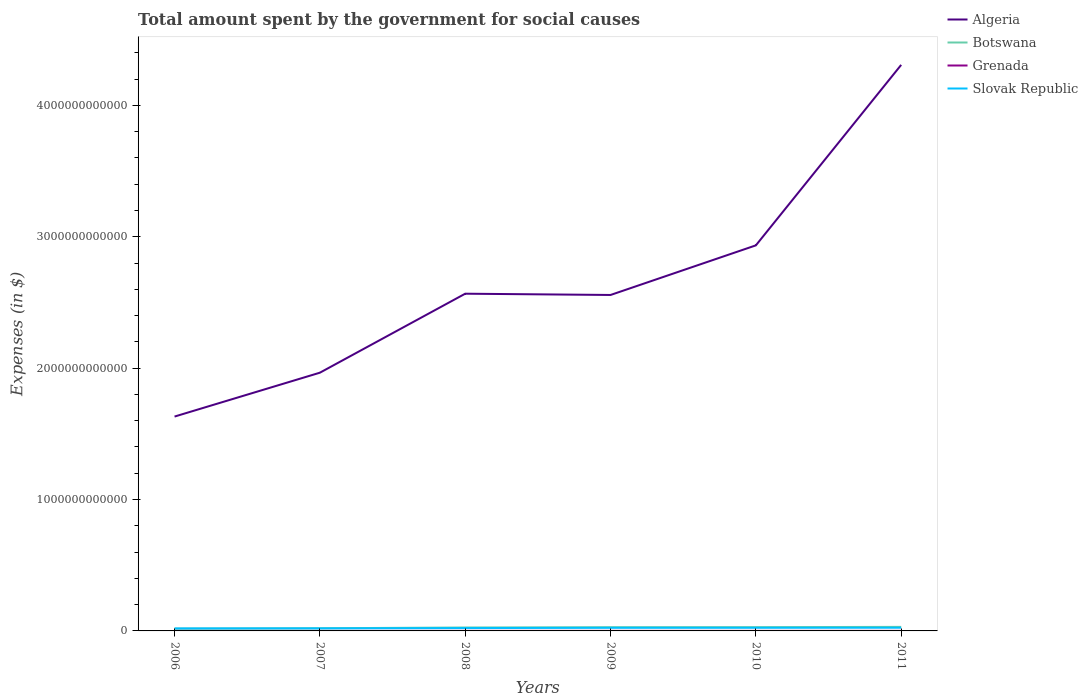How many different coloured lines are there?
Give a very brief answer. 4. Does the line corresponding to Algeria intersect with the line corresponding to Slovak Republic?
Offer a very short reply. No. Across all years, what is the maximum amount spent for social causes by the government in Slovak Republic?
Offer a terse response. 1.91e+1. What is the total amount spent for social causes by the government in Slovak Republic in the graph?
Offer a very short reply. -4.88e+09. What is the difference between the highest and the second highest amount spent for social causes by the government in Botswana?
Provide a succinct answer. 1.38e+1. What is the difference between the highest and the lowest amount spent for social causes by the government in Grenada?
Your answer should be compact. 4. What is the difference between two consecutive major ticks on the Y-axis?
Provide a short and direct response. 1.00e+12. Does the graph contain any zero values?
Ensure brevity in your answer.  No. How many legend labels are there?
Offer a very short reply. 4. What is the title of the graph?
Make the answer very short. Total amount spent by the government for social causes. Does "Vanuatu" appear as one of the legend labels in the graph?
Provide a short and direct response. No. What is the label or title of the X-axis?
Provide a short and direct response. Years. What is the label or title of the Y-axis?
Offer a very short reply. Expenses (in $). What is the Expenses (in $) in Algeria in 2006?
Ensure brevity in your answer.  1.63e+12. What is the Expenses (in $) in Botswana in 2006?
Ensure brevity in your answer.  1.70e+1. What is the Expenses (in $) of Grenada in 2006?
Offer a very short reply. 3.18e+08. What is the Expenses (in $) of Slovak Republic in 2006?
Make the answer very short. 1.91e+1. What is the Expenses (in $) in Algeria in 2007?
Keep it short and to the point. 1.97e+12. What is the Expenses (in $) of Botswana in 2007?
Ensure brevity in your answer.  2.02e+1. What is the Expenses (in $) of Grenada in 2007?
Your answer should be very brief. 3.46e+08. What is the Expenses (in $) of Slovak Republic in 2007?
Keep it short and to the point. 1.96e+1. What is the Expenses (in $) of Algeria in 2008?
Provide a succinct answer. 2.57e+12. What is the Expenses (in $) in Botswana in 2008?
Give a very brief answer. 2.62e+1. What is the Expenses (in $) of Grenada in 2008?
Your response must be concise. 4.14e+08. What is the Expenses (in $) in Slovak Republic in 2008?
Give a very brief answer. 2.16e+1. What is the Expenses (in $) in Algeria in 2009?
Provide a succinct answer. 2.56e+12. What is the Expenses (in $) of Botswana in 2009?
Offer a very short reply. 2.84e+1. What is the Expenses (in $) in Grenada in 2009?
Your response must be concise. 4.17e+08. What is the Expenses (in $) in Slovak Republic in 2009?
Give a very brief answer. 2.37e+1. What is the Expenses (in $) of Algeria in 2010?
Provide a succinct answer. 2.93e+12. What is the Expenses (in $) in Botswana in 2010?
Ensure brevity in your answer.  2.88e+1. What is the Expenses (in $) of Grenada in 2010?
Your answer should be very brief. 4.08e+08. What is the Expenses (in $) of Slovak Republic in 2010?
Give a very brief answer. 2.40e+1. What is the Expenses (in $) of Algeria in 2011?
Offer a terse response. 4.31e+12. What is the Expenses (in $) of Botswana in 2011?
Provide a short and direct response. 3.08e+1. What is the Expenses (in $) of Grenada in 2011?
Provide a succinct answer. 4.21e+08. What is the Expenses (in $) of Slovak Republic in 2011?
Your answer should be very brief. 2.44e+1. Across all years, what is the maximum Expenses (in $) of Algeria?
Make the answer very short. 4.31e+12. Across all years, what is the maximum Expenses (in $) in Botswana?
Offer a very short reply. 3.08e+1. Across all years, what is the maximum Expenses (in $) of Grenada?
Your answer should be very brief. 4.21e+08. Across all years, what is the maximum Expenses (in $) of Slovak Republic?
Keep it short and to the point. 2.44e+1. Across all years, what is the minimum Expenses (in $) in Algeria?
Provide a short and direct response. 1.63e+12. Across all years, what is the minimum Expenses (in $) in Botswana?
Keep it short and to the point. 1.70e+1. Across all years, what is the minimum Expenses (in $) of Grenada?
Your response must be concise. 3.18e+08. Across all years, what is the minimum Expenses (in $) in Slovak Republic?
Offer a terse response. 1.91e+1. What is the total Expenses (in $) of Algeria in the graph?
Provide a short and direct response. 1.60e+13. What is the total Expenses (in $) in Botswana in the graph?
Ensure brevity in your answer.  1.51e+11. What is the total Expenses (in $) of Grenada in the graph?
Make the answer very short. 2.32e+09. What is the total Expenses (in $) in Slovak Republic in the graph?
Your answer should be very brief. 1.33e+11. What is the difference between the Expenses (in $) in Algeria in 2006 and that in 2007?
Your response must be concise. -3.34e+11. What is the difference between the Expenses (in $) in Botswana in 2006 and that in 2007?
Make the answer very short. -3.24e+09. What is the difference between the Expenses (in $) in Grenada in 2006 and that in 2007?
Your answer should be very brief. -2.85e+07. What is the difference between the Expenses (in $) in Slovak Republic in 2006 and that in 2007?
Your answer should be very brief. -4.96e+08. What is the difference between the Expenses (in $) of Algeria in 2006 and that in 2008?
Your response must be concise. -9.35e+11. What is the difference between the Expenses (in $) in Botswana in 2006 and that in 2008?
Your answer should be compact. -9.23e+09. What is the difference between the Expenses (in $) in Grenada in 2006 and that in 2008?
Provide a short and direct response. -9.61e+07. What is the difference between the Expenses (in $) of Slovak Republic in 2006 and that in 2008?
Make the answer very short. -2.50e+09. What is the difference between the Expenses (in $) in Algeria in 2006 and that in 2009?
Make the answer very short. -9.25e+11. What is the difference between the Expenses (in $) in Botswana in 2006 and that in 2009?
Offer a very short reply. -1.14e+1. What is the difference between the Expenses (in $) of Grenada in 2006 and that in 2009?
Your answer should be compact. -9.91e+07. What is the difference between the Expenses (in $) of Slovak Republic in 2006 and that in 2009?
Provide a succinct answer. -4.61e+09. What is the difference between the Expenses (in $) in Algeria in 2006 and that in 2010?
Offer a terse response. -1.30e+12. What is the difference between the Expenses (in $) of Botswana in 2006 and that in 2010?
Ensure brevity in your answer.  -1.18e+1. What is the difference between the Expenses (in $) in Grenada in 2006 and that in 2010?
Provide a short and direct response. -9.10e+07. What is the difference between the Expenses (in $) of Slovak Republic in 2006 and that in 2010?
Give a very brief answer. -4.88e+09. What is the difference between the Expenses (in $) in Algeria in 2006 and that in 2011?
Your response must be concise. -2.68e+12. What is the difference between the Expenses (in $) of Botswana in 2006 and that in 2011?
Ensure brevity in your answer.  -1.38e+1. What is the difference between the Expenses (in $) in Grenada in 2006 and that in 2011?
Your answer should be compact. -1.03e+08. What is the difference between the Expenses (in $) of Slovak Republic in 2006 and that in 2011?
Give a very brief answer. -5.24e+09. What is the difference between the Expenses (in $) in Algeria in 2007 and that in 2008?
Provide a succinct answer. -6.01e+11. What is the difference between the Expenses (in $) in Botswana in 2007 and that in 2008?
Provide a short and direct response. -5.98e+09. What is the difference between the Expenses (in $) in Grenada in 2007 and that in 2008?
Give a very brief answer. -6.76e+07. What is the difference between the Expenses (in $) of Slovak Republic in 2007 and that in 2008?
Your response must be concise. -2.01e+09. What is the difference between the Expenses (in $) of Algeria in 2007 and that in 2009?
Provide a succinct answer. -5.92e+11. What is the difference between the Expenses (in $) of Botswana in 2007 and that in 2009?
Your answer should be very brief. -8.16e+09. What is the difference between the Expenses (in $) in Grenada in 2007 and that in 2009?
Your answer should be very brief. -7.06e+07. What is the difference between the Expenses (in $) in Slovak Republic in 2007 and that in 2009?
Ensure brevity in your answer.  -4.11e+09. What is the difference between the Expenses (in $) in Algeria in 2007 and that in 2010?
Your answer should be very brief. -9.69e+11. What is the difference between the Expenses (in $) in Botswana in 2007 and that in 2010?
Keep it short and to the point. -8.57e+09. What is the difference between the Expenses (in $) of Grenada in 2007 and that in 2010?
Provide a succinct answer. -6.25e+07. What is the difference between the Expenses (in $) in Slovak Republic in 2007 and that in 2010?
Your answer should be very brief. -4.38e+09. What is the difference between the Expenses (in $) of Algeria in 2007 and that in 2011?
Offer a very short reply. -2.34e+12. What is the difference between the Expenses (in $) in Botswana in 2007 and that in 2011?
Provide a succinct answer. -1.06e+1. What is the difference between the Expenses (in $) in Grenada in 2007 and that in 2011?
Make the answer very short. -7.48e+07. What is the difference between the Expenses (in $) of Slovak Republic in 2007 and that in 2011?
Provide a succinct answer. -4.74e+09. What is the difference between the Expenses (in $) of Algeria in 2008 and that in 2009?
Offer a very short reply. 9.64e+09. What is the difference between the Expenses (in $) of Botswana in 2008 and that in 2009?
Offer a very short reply. -2.17e+09. What is the difference between the Expenses (in $) of Slovak Republic in 2008 and that in 2009?
Offer a terse response. -2.10e+09. What is the difference between the Expenses (in $) in Algeria in 2008 and that in 2010?
Give a very brief answer. -3.68e+11. What is the difference between the Expenses (in $) of Botswana in 2008 and that in 2010?
Provide a succinct answer. -2.58e+09. What is the difference between the Expenses (in $) of Grenada in 2008 and that in 2010?
Give a very brief answer. 5.10e+06. What is the difference between the Expenses (in $) in Slovak Republic in 2008 and that in 2010?
Ensure brevity in your answer.  -2.37e+09. What is the difference between the Expenses (in $) of Algeria in 2008 and that in 2011?
Your response must be concise. -1.74e+12. What is the difference between the Expenses (in $) in Botswana in 2008 and that in 2011?
Offer a terse response. -4.59e+09. What is the difference between the Expenses (in $) in Grenada in 2008 and that in 2011?
Offer a terse response. -7.20e+06. What is the difference between the Expenses (in $) in Slovak Republic in 2008 and that in 2011?
Give a very brief answer. -2.74e+09. What is the difference between the Expenses (in $) of Algeria in 2009 and that in 2010?
Provide a succinct answer. -3.78e+11. What is the difference between the Expenses (in $) of Botswana in 2009 and that in 2010?
Your response must be concise. -4.12e+08. What is the difference between the Expenses (in $) in Grenada in 2009 and that in 2010?
Offer a terse response. 8.10e+06. What is the difference between the Expenses (in $) in Slovak Republic in 2009 and that in 2010?
Your answer should be compact. -2.73e+08. What is the difference between the Expenses (in $) of Algeria in 2009 and that in 2011?
Make the answer very short. -1.75e+12. What is the difference between the Expenses (in $) in Botswana in 2009 and that in 2011?
Your answer should be compact. -2.42e+09. What is the difference between the Expenses (in $) of Grenada in 2009 and that in 2011?
Your response must be concise. -4.20e+06. What is the difference between the Expenses (in $) of Slovak Republic in 2009 and that in 2011?
Ensure brevity in your answer.  -6.35e+08. What is the difference between the Expenses (in $) of Algeria in 2010 and that in 2011?
Keep it short and to the point. -1.37e+12. What is the difference between the Expenses (in $) of Botswana in 2010 and that in 2011?
Ensure brevity in your answer.  -2.00e+09. What is the difference between the Expenses (in $) in Grenada in 2010 and that in 2011?
Provide a short and direct response. -1.23e+07. What is the difference between the Expenses (in $) in Slovak Republic in 2010 and that in 2011?
Provide a succinct answer. -3.62e+08. What is the difference between the Expenses (in $) in Algeria in 2006 and the Expenses (in $) in Botswana in 2007?
Provide a succinct answer. 1.61e+12. What is the difference between the Expenses (in $) in Algeria in 2006 and the Expenses (in $) in Grenada in 2007?
Offer a very short reply. 1.63e+12. What is the difference between the Expenses (in $) of Algeria in 2006 and the Expenses (in $) of Slovak Republic in 2007?
Make the answer very short. 1.61e+12. What is the difference between the Expenses (in $) in Botswana in 2006 and the Expenses (in $) in Grenada in 2007?
Make the answer very short. 1.66e+1. What is the difference between the Expenses (in $) of Botswana in 2006 and the Expenses (in $) of Slovak Republic in 2007?
Make the answer very short. -2.67e+09. What is the difference between the Expenses (in $) in Grenada in 2006 and the Expenses (in $) in Slovak Republic in 2007?
Give a very brief answer. -1.93e+1. What is the difference between the Expenses (in $) in Algeria in 2006 and the Expenses (in $) in Botswana in 2008?
Provide a short and direct response. 1.61e+12. What is the difference between the Expenses (in $) in Algeria in 2006 and the Expenses (in $) in Grenada in 2008?
Make the answer very short. 1.63e+12. What is the difference between the Expenses (in $) of Algeria in 2006 and the Expenses (in $) of Slovak Republic in 2008?
Give a very brief answer. 1.61e+12. What is the difference between the Expenses (in $) in Botswana in 2006 and the Expenses (in $) in Grenada in 2008?
Provide a short and direct response. 1.66e+1. What is the difference between the Expenses (in $) in Botswana in 2006 and the Expenses (in $) in Slovak Republic in 2008?
Provide a succinct answer. -4.68e+09. What is the difference between the Expenses (in $) in Grenada in 2006 and the Expenses (in $) in Slovak Republic in 2008?
Offer a very short reply. -2.13e+1. What is the difference between the Expenses (in $) of Algeria in 2006 and the Expenses (in $) of Botswana in 2009?
Offer a terse response. 1.60e+12. What is the difference between the Expenses (in $) of Algeria in 2006 and the Expenses (in $) of Grenada in 2009?
Provide a succinct answer. 1.63e+12. What is the difference between the Expenses (in $) in Algeria in 2006 and the Expenses (in $) in Slovak Republic in 2009?
Ensure brevity in your answer.  1.61e+12. What is the difference between the Expenses (in $) in Botswana in 2006 and the Expenses (in $) in Grenada in 2009?
Offer a terse response. 1.65e+1. What is the difference between the Expenses (in $) of Botswana in 2006 and the Expenses (in $) of Slovak Republic in 2009?
Your response must be concise. -6.78e+09. What is the difference between the Expenses (in $) in Grenada in 2006 and the Expenses (in $) in Slovak Republic in 2009?
Ensure brevity in your answer.  -2.34e+1. What is the difference between the Expenses (in $) of Algeria in 2006 and the Expenses (in $) of Botswana in 2010?
Offer a terse response. 1.60e+12. What is the difference between the Expenses (in $) of Algeria in 2006 and the Expenses (in $) of Grenada in 2010?
Keep it short and to the point. 1.63e+12. What is the difference between the Expenses (in $) in Algeria in 2006 and the Expenses (in $) in Slovak Republic in 2010?
Keep it short and to the point. 1.61e+12. What is the difference between the Expenses (in $) of Botswana in 2006 and the Expenses (in $) of Grenada in 2010?
Provide a succinct answer. 1.66e+1. What is the difference between the Expenses (in $) of Botswana in 2006 and the Expenses (in $) of Slovak Republic in 2010?
Offer a terse response. -7.05e+09. What is the difference between the Expenses (in $) in Grenada in 2006 and the Expenses (in $) in Slovak Republic in 2010?
Your answer should be compact. -2.37e+1. What is the difference between the Expenses (in $) of Algeria in 2006 and the Expenses (in $) of Botswana in 2011?
Keep it short and to the point. 1.60e+12. What is the difference between the Expenses (in $) of Algeria in 2006 and the Expenses (in $) of Grenada in 2011?
Keep it short and to the point. 1.63e+12. What is the difference between the Expenses (in $) of Algeria in 2006 and the Expenses (in $) of Slovak Republic in 2011?
Your response must be concise. 1.61e+12. What is the difference between the Expenses (in $) of Botswana in 2006 and the Expenses (in $) of Grenada in 2011?
Make the answer very short. 1.65e+1. What is the difference between the Expenses (in $) of Botswana in 2006 and the Expenses (in $) of Slovak Republic in 2011?
Offer a terse response. -7.41e+09. What is the difference between the Expenses (in $) of Grenada in 2006 and the Expenses (in $) of Slovak Republic in 2011?
Your answer should be very brief. -2.41e+1. What is the difference between the Expenses (in $) of Algeria in 2007 and the Expenses (in $) of Botswana in 2008?
Your answer should be compact. 1.94e+12. What is the difference between the Expenses (in $) of Algeria in 2007 and the Expenses (in $) of Grenada in 2008?
Ensure brevity in your answer.  1.96e+12. What is the difference between the Expenses (in $) of Algeria in 2007 and the Expenses (in $) of Slovak Republic in 2008?
Provide a short and direct response. 1.94e+12. What is the difference between the Expenses (in $) of Botswana in 2007 and the Expenses (in $) of Grenada in 2008?
Your response must be concise. 1.98e+1. What is the difference between the Expenses (in $) of Botswana in 2007 and the Expenses (in $) of Slovak Republic in 2008?
Keep it short and to the point. -1.44e+09. What is the difference between the Expenses (in $) of Grenada in 2007 and the Expenses (in $) of Slovak Republic in 2008?
Provide a short and direct response. -2.13e+1. What is the difference between the Expenses (in $) of Algeria in 2007 and the Expenses (in $) of Botswana in 2009?
Give a very brief answer. 1.94e+12. What is the difference between the Expenses (in $) of Algeria in 2007 and the Expenses (in $) of Grenada in 2009?
Give a very brief answer. 1.96e+12. What is the difference between the Expenses (in $) of Algeria in 2007 and the Expenses (in $) of Slovak Republic in 2009?
Ensure brevity in your answer.  1.94e+12. What is the difference between the Expenses (in $) in Botswana in 2007 and the Expenses (in $) in Grenada in 2009?
Provide a short and direct response. 1.98e+1. What is the difference between the Expenses (in $) in Botswana in 2007 and the Expenses (in $) in Slovak Republic in 2009?
Your answer should be very brief. -3.54e+09. What is the difference between the Expenses (in $) of Grenada in 2007 and the Expenses (in $) of Slovak Republic in 2009?
Offer a terse response. -2.34e+1. What is the difference between the Expenses (in $) in Algeria in 2007 and the Expenses (in $) in Botswana in 2010?
Provide a short and direct response. 1.94e+12. What is the difference between the Expenses (in $) of Algeria in 2007 and the Expenses (in $) of Grenada in 2010?
Provide a succinct answer. 1.96e+12. What is the difference between the Expenses (in $) in Algeria in 2007 and the Expenses (in $) in Slovak Republic in 2010?
Offer a terse response. 1.94e+12. What is the difference between the Expenses (in $) in Botswana in 2007 and the Expenses (in $) in Grenada in 2010?
Keep it short and to the point. 1.98e+1. What is the difference between the Expenses (in $) of Botswana in 2007 and the Expenses (in $) of Slovak Republic in 2010?
Make the answer very short. -3.81e+09. What is the difference between the Expenses (in $) of Grenada in 2007 and the Expenses (in $) of Slovak Republic in 2010?
Your response must be concise. -2.37e+1. What is the difference between the Expenses (in $) of Algeria in 2007 and the Expenses (in $) of Botswana in 2011?
Offer a terse response. 1.93e+12. What is the difference between the Expenses (in $) in Algeria in 2007 and the Expenses (in $) in Grenada in 2011?
Give a very brief answer. 1.96e+12. What is the difference between the Expenses (in $) of Algeria in 2007 and the Expenses (in $) of Slovak Republic in 2011?
Offer a terse response. 1.94e+12. What is the difference between the Expenses (in $) of Botswana in 2007 and the Expenses (in $) of Grenada in 2011?
Your response must be concise. 1.98e+1. What is the difference between the Expenses (in $) of Botswana in 2007 and the Expenses (in $) of Slovak Republic in 2011?
Your response must be concise. -4.17e+09. What is the difference between the Expenses (in $) in Grenada in 2007 and the Expenses (in $) in Slovak Republic in 2011?
Your answer should be very brief. -2.40e+1. What is the difference between the Expenses (in $) of Algeria in 2008 and the Expenses (in $) of Botswana in 2009?
Your answer should be very brief. 2.54e+12. What is the difference between the Expenses (in $) in Algeria in 2008 and the Expenses (in $) in Grenada in 2009?
Offer a terse response. 2.57e+12. What is the difference between the Expenses (in $) of Algeria in 2008 and the Expenses (in $) of Slovak Republic in 2009?
Ensure brevity in your answer.  2.54e+12. What is the difference between the Expenses (in $) in Botswana in 2008 and the Expenses (in $) in Grenada in 2009?
Your response must be concise. 2.58e+1. What is the difference between the Expenses (in $) of Botswana in 2008 and the Expenses (in $) of Slovak Republic in 2009?
Your answer should be compact. 2.45e+09. What is the difference between the Expenses (in $) of Grenada in 2008 and the Expenses (in $) of Slovak Republic in 2009?
Keep it short and to the point. -2.33e+1. What is the difference between the Expenses (in $) of Algeria in 2008 and the Expenses (in $) of Botswana in 2010?
Your answer should be compact. 2.54e+12. What is the difference between the Expenses (in $) in Algeria in 2008 and the Expenses (in $) in Grenada in 2010?
Offer a very short reply. 2.57e+12. What is the difference between the Expenses (in $) in Algeria in 2008 and the Expenses (in $) in Slovak Republic in 2010?
Give a very brief answer. 2.54e+12. What is the difference between the Expenses (in $) in Botswana in 2008 and the Expenses (in $) in Grenada in 2010?
Offer a terse response. 2.58e+1. What is the difference between the Expenses (in $) in Botswana in 2008 and the Expenses (in $) in Slovak Republic in 2010?
Keep it short and to the point. 2.17e+09. What is the difference between the Expenses (in $) in Grenada in 2008 and the Expenses (in $) in Slovak Republic in 2010?
Provide a succinct answer. -2.36e+1. What is the difference between the Expenses (in $) in Algeria in 2008 and the Expenses (in $) in Botswana in 2011?
Offer a very short reply. 2.54e+12. What is the difference between the Expenses (in $) of Algeria in 2008 and the Expenses (in $) of Grenada in 2011?
Give a very brief answer. 2.57e+12. What is the difference between the Expenses (in $) in Algeria in 2008 and the Expenses (in $) in Slovak Republic in 2011?
Offer a very short reply. 2.54e+12. What is the difference between the Expenses (in $) of Botswana in 2008 and the Expenses (in $) of Grenada in 2011?
Your answer should be very brief. 2.58e+1. What is the difference between the Expenses (in $) in Botswana in 2008 and the Expenses (in $) in Slovak Republic in 2011?
Your response must be concise. 1.81e+09. What is the difference between the Expenses (in $) of Grenada in 2008 and the Expenses (in $) of Slovak Republic in 2011?
Keep it short and to the point. -2.40e+1. What is the difference between the Expenses (in $) in Algeria in 2009 and the Expenses (in $) in Botswana in 2010?
Your answer should be very brief. 2.53e+12. What is the difference between the Expenses (in $) of Algeria in 2009 and the Expenses (in $) of Grenada in 2010?
Your answer should be compact. 2.56e+12. What is the difference between the Expenses (in $) of Algeria in 2009 and the Expenses (in $) of Slovak Republic in 2010?
Provide a short and direct response. 2.53e+12. What is the difference between the Expenses (in $) of Botswana in 2009 and the Expenses (in $) of Grenada in 2010?
Give a very brief answer. 2.80e+1. What is the difference between the Expenses (in $) in Botswana in 2009 and the Expenses (in $) in Slovak Republic in 2010?
Provide a short and direct response. 4.35e+09. What is the difference between the Expenses (in $) in Grenada in 2009 and the Expenses (in $) in Slovak Republic in 2010?
Give a very brief answer. -2.36e+1. What is the difference between the Expenses (in $) in Algeria in 2009 and the Expenses (in $) in Botswana in 2011?
Offer a very short reply. 2.53e+12. What is the difference between the Expenses (in $) of Algeria in 2009 and the Expenses (in $) of Grenada in 2011?
Give a very brief answer. 2.56e+12. What is the difference between the Expenses (in $) of Algeria in 2009 and the Expenses (in $) of Slovak Republic in 2011?
Ensure brevity in your answer.  2.53e+12. What is the difference between the Expenses (in $) in Botswana in 2009 and the Expenses (in $) in Grenada in 2011?
Keep it short and to the point. 2.79e+1. What is the difference between the Expenses (in $) in Botswana in 2009 and the Expenses (in $) in Slovak Republic in 2011?
Ensure brevity in your answer.  3.98e+09. What is the difference between the Expenses (in $) in Grenada in 2009 and the Expenses (in $) in Slovak Republic in 2011?
Ensure brevity in your answer.  -2.40e+1. What is the difference between the Expenses (in $) of Algeria in 2010 and the Expenses (in $) of Botswana in 2011?
Ensure brevity in your answer.  2.90e+12. What is the difference between the Expenses (in $) in Algeria in 2010 and the Expenses (in $) in Grenada in 2011?
Keep it short and to the point. 2.93e+12. What is the difference between the Expenses (in $) of Algeria in 2010 and the Expenses (in $) of Slovak Republic in 2011?
Your answer should be compact. 2.91e+12. What is the difference between the Expenses (in $) of Botswana in 2010 and the Expenses (in $) of Grenada in 2011?
Keep it short and to the point. 2.84e+1. What is the difference between the Expenses (in $) in Botswana in 2010 and the Expenses (in $) in Slovak Republic in 2011?
Provide a short and direct response. 4.40e+09. What is the difference between the Expenses (in $) of Grenada in 2010 and the Expenses (in $) of Slovak Republic in 2011?
Keep it short and to the point. -2.40e+1. What is the average Expenses (in $) of Algeria per year?
Provide a succinct answer. 2.66e+12. What is the average Expenses (in $) in Botswana per year?
Make the answer very short. 2.52e+1. What is the average Expenses (in $) of Grenada per year?
Your answer should be very brief. 3.87e+08. What is the average Expenses (in $) in Slovak Republic per year?
Offer a terse response. 2.21e+1. In the year 2006, what is the difference between the Expenses (in $) in Algeria and Expenses (in $) in Botswana?
Keep it short and to the point. 1.61e+12. In the year 2006, what is the difference between the Expenses (in $) of Algeria and Expenses (in $) of Grenada?
Your response must be concise. 1.63e+12. In the year 2006, what is the difference between the Expenses (in $) of Algeria and Expenses (in $) of Slovak Republic?
Offer a terse response. 1.61e+12. In the year 2006, what is the difference between the Expenses (in $) of Botswana and Expenses (in $) of Grenada?
Offer a very short reply. 1.66e+1. In the year 2006, what is the difference between the Expenses (in $) in Botswana and Expenses (in $) in Slovak Republic?
Ensure brevity in your answer.  -2.17e+09. In the year 2006, what is the difference between the Expenses (in $) of Grenada and Expenses (in $) of Slovak Republic?
Offer a very short reply. -1.88e+1. In the year 2007, what is the difference between the Expenses (in $) in Algeria and Expenses (in $) in Botswana?
Offer a terse response. 1.95e+12. In the year 2007, what is the difference between the Expenses (in $) of Algeria and Expenses (in $) of Grenada?
Your answer should be compact. 1.96e+12. In the year 2007, what is the difference between the Expenses (in $) of Algeria and Expenses (in $) of Slovak Republic?
Your answer should be very brief. 1.95e+12. In the year 2007, what is the difference between the Expenses (in $) in Botswana and Expenses (in $) in Grenada?
Provide a short and direct response. 1.99e+1. In the year 2007, what is the difference between the Expenses (in $) in Botswana and Expenses (in $) in Slovak Republic?
Provide a short and direct response. 5.72e+08. In the year 2007, what is the difference between the Expenses (in $) of Grenada and Expenses (in $) of Slovak Republic?
Make the answer very short. -1.93e+1. In the year 2008, what is the difference between the Expenses (in $) in Algeria and Expenses (in $) in Botswana?
Provide a succinct answer. 2.54e+12. In the year 2008, what is the difference between the Expenses (in $) of Algeria and Expenses (in $) of Grenada?
Offer a terse response. 2.57e+12. In the year 2008, what is the difference between the Expenses (in $) in Algeria and Expenses (in $) in Slovak Republic?
Keep it short and to the point. 2.54e+12. In the year 2008, what is the difference between the Expenses (in $) in Botswana and Expenses (in $) in Grenada?
Ensure brevity in your answer.  2.58e+1. In the year 2008, what is the difference between the Expenses (in $) in Botswana and Expenses (in $) in Slovak Republic?
Ensure brevity in your answer.  4.55e+09. In the year 2008, what is the difference between the Expenses (in $) in Grenada and Expenses (in $) in Slovak Republic?
Your response must be concise. -2.12e+1. In the year 2009, what is the difference between the Expenses (in $) in Algeria and Expenses (in $) in Botswana?
Your answer should be very brief. 2.53e+12. In the year 2009, what is the difference between the Expenses (in $) in Algeria and Expenses (in $) in Grenada?
Ensure brevity in your answer.  2.56e+12. In the year 2009, what is the difference between the Expenses (in $) in Algeria and Expenses (in $) in Slovak Republic?
Offer a very short reply. 2.53e+12. In the year 2009, what is the difference between the Expenses (in $) of Botswana and Expenses (in $) of Grenada?
Your response must be concise. 2.79e+1. In the year 2009, what is the difference between the Expenses (in $) of Botswana and Expenses (in $) of Slovak Republic?
Your answer should be very brief. 4.62e+09. In the year 2009, what is the difference between the Expenses (in $) of Grenada and Expenses (in $) of Slovak Republic?
Your response must be concise. -2.33e+1. In the year 2010, what is the difference between the Expenses (in $) in Algeria and Expenses (in $) in Botswana?
Your answer should be compact. 2.91e+12. In the year 2010, what is the difference between the Expenses (in $) of Algeria and Expenses (in $) of Grenada?
Your answer should be compact. 2.93e+12. In the year 2010, what is the difference between the Expenses (in $) of Algeria and Expenses (in $) of Slovak Republic?
Your answer should be compact. 2.91e+12. In the year 2010, what is the difference between the Expenses (in $) in Botswana and Expenses (in $) in Grenada?
Your answer should be compact. 2.84e+1. In the year 2010, what is the difference between the Expenses (in $) of Botswana and Expenses (in $) of Slovak Republic?
Make the answer very short. 4.76e+09. In the year 2010, what is the difference between the Expenses (in $) in Grenada and Expenses (in $) in Slovak Republic?
Offer a terse response. -2.36e+1. In the year 2011, what is the difference between the Expenses (in $) of Algeria and Expenses (in $) of Botswana?
Provide a short and direct response. 4.28e+12. In the year 2011, what is the difference between the Expenses (in $) in Algeria and Expenses (in $) in Grenada?
Ensure brevity in your answer.  4.31e+12. In the year 2011, what is the difference between the Expenses (in $) of Algeria and Expenses (in $) of Slovak Republic?
Ensure brevity in your answer.  4.28e+12. In the year 2011, what is the difference between the Expenses (in $) of Botswana and Expenses (in $) of Grenada?
Provide a succinct answer. 3.04e+1. In the year 2011, what is the difference between the Expenses (in $) of Botswana and Expenses (in $) of Slovak Republic?
Ensure brevity in your answer.  6.40e+09. In the year 2011, what is the difference between the Expenses (in $) of Grenada and Expenses (in $) of Slovak Republic?
Keep it short and to the point. -2.40e+1. What is the ratio of the Expenses (in $) in Algeria in 2006 to that in 2007?
Your response must be concise. 0.83. What is the ratio of the Expenses (in $) in Botswana in 2006 to that in 2007?
Offer a very short reply. 0.84. What is the ratio of the Expenses (in $) of Grenada in 2006 to that in 2007?
Your answer should be very brief. 0.92. What is the ratio of the Expenses (in $) of Slovak Republic in 2006 to that in 2007?
Your response must be concise. 0.97. What is the ratio of the Expenses (in $) of Algeria in 2006 to that in 2008?
Offer a terse response. 0.64. What is the ratio of the Expenses (in $) of Botswana in 2006 to that in 2008?
Make the answer very short. 0.65. What is the ratio of the Expenses (in $) in Grenada in 2006 to that in 2008?
Your response must be concise. 0.77. What is the ratio of the Expenses (in $) in Slovak Republic in 2006 to that in 2008?
Your answer should be compact. 0.88. What is the ratio of the Expenses (in $) of Algeria in 2006 to that in 2009?
Provide a succinct answer. 0.64. What is the ratio of the Expenses (in $) in Botswana in 2006 to that in 2009?
Your answer should be very brief. 0.6. What is the ratio of the Expenses (in $) of Grenada in 2006 to that in 2009?
Offer a terse response. 0.76. What is the ratio of the Expenses (in $) of Slovak Republic in 2006 to that in 2009?
Your answer should be very brief. 0.81. What is the ratio of the Expenses (in $) in Algeria in 2006 to that in 2010?
Make the answer very short. 0.56. What is the ratio of the Expenses (in $) in Botswana in 2006 to that in 2010?
Keep it short and to the point. 0.59. What is the ratio of the Expenses (in $) in Grenada in 2006 to that in 2010?
Provide a short and direct response. 0.78. What is the ratio of the Expenses (in $) in Slovak Republic in 2006 to that in 2010?
Offer a very short reply. 0.8. What is the ratio of the Expenses (in $) of Algeria in 2006 to that in 2011?
Offer a terse response. 0.38. What is the ratio of the Expenses (in $) in Botswana in 2006 to that in 2011?
Offer a terse response. 0.55. What is the ratio of the Expenses (in $) in Grenada in 2006 to that in 2011?
Ensure brevity in your answer.  0.75. What is the ratio of the Expenses (in $) in Slovak Republic in 2006 to that in 2011?
Offer a very short reply. 0.79. What is the ratio of the Expenses (in $) in Algeria in 2007 to that in 2008?
Provide a short and direct response. 0.77. What is the ratio of the Expenses (in $) in Botswana in 2007 to that in 2008?
Keep it short and to the point. 0.77. What is the ratio of the Expenses (in $) in Grenada in 2007 to that in 2008?
Offer a very short reply. 0.84. What is the ratio of the Expenses (in $) of Slovak Republic in 2007 to that in 2008?
Provide a short and direct response. 0.91. What is the ratio of the Expenses (in $) of Algeria in 2007 to that in 2009?
Keep it short and to the point. 0.77. What is the ratio of the Expenses (in $) in Botswana in 2007 to that in 2009?
Make the answer very short. 0.71. What is the ratio of the Expenses (in $) of Grenada in 2007 to that in 2009?
Offer a terse response. 0.83. What is the ratio of the Expenses (in $) of Slovak Republic in 2007 to that in 2009?
Provide a short and direct response. 0.83. What is the ratio of the Expenses (in $) of Algeria in 2007 to that in 2010?
Give a very brief answer. 0.67. What is the ratio of the Expenses (in $) in Botswana in 2007 to that in 2010?
Give a very brief answer. 0.7. What is the ratio of the Expenses (in $) of Grenada in 2007 to that in 2010?
Your answer should be very brief. 0.85. What is the ratio of the Expenses (in $) in Slovak Republic in 2007 to that in 2010?
Provide a succinct answer. 0.82. What is the ratio of the Expenses (in $) in Algeria in 2007 to that in 2011?
Give a very brief answer. 0.46. What is the ratio of the Expenses (in $) in Botswana in 2007 to that in 2011?
Provide a succinct answer. 0.66. What is the ratio of the Expenses (in $) in Grenada in 2007 to that in 2011?
Offer a terse response. 0.82. What is the ratio of the Expenses (in $) of Slovak Republic in 2007 to that in 2011?
Offer a very short reply. 0.81. What is the ratio of the Expenses (in $) of Botswana in 2008 to that in 2009?
Provide a short and direct response. 0.92. What is the ratio of the Expenses (in $) in Grenada in 2008 to that in 2009?
Offer a terse response. 0.99. What is the ratio of the Expenses (in $) in Slovak Republic in 2008 to that in 2009?
Your answer should be very brief. 0.91. What is the ratio of the Expenses (in $) of Algeria in 2008 to that in 2010?
Offer a terse response. 0.87. What is the ratio of the Expenses (in $) in Botswana in 2008 to that in 2010?
Give a very brief answer. 0.91. What is the ratio of the Expenses (in $) of Grenada in 2008 to that in 2010?
Give a very brief answer. 1.01. What is the ratio of the Expenses (in $) in Slovak Republic in 2008 to that in 2010?
Provide a short and direct response. 0.9. What is the ratio of the Expenses (in $) of Algeria in 2008 to that in 2011?
Ensure brevity in your answer.  0.6. What is the ratio of the Expenses (in $) of Botswana in 2008 to that in 2011?
Your answer should be very brief. 0.85. What is the ratio of the Expenses (in $) in Grenada in 2008 to that in 2011?
Your answer should be very brief. 0.98. What is the ratio of the Expenses (in $) of Slovak Republic in 2008 to that in 2011?
Ensure brevity in your answer.  0.89. What is the ratio of the Expenses (in $) in Algeria in 2009 to that in 2010?
Keep it short and to the point. 0.87. What is the ratio of the Expenses (in $) of Botswana in 2009 to that in 2010?
Your answer should be compact. 0.99. What is the ratio of the Expenses (in $) in Grenada in 2009 to that in 2010?
Ensure brevity in your answer.  1.02. What is the ratio of the Expenses (in $) in Slovak Republic in 2009 to that in 2010?
Provide a succinct answer. 0.99. What is the ratio of the Expenses (in $) of Algeria in 2009 to that in 2011?
Offer a very short reply. 0.59. What is the ratio of the Expenses (in $) of Botswana in 2009 to that in 2011?
Ensure brevity in your answer.  0.92. What is the ratio of the Expenses (in $) in Grenada in 2009 to that in 2011?
Make the answer very short. 0.99. What is the ratio of the Expenses (in $) in Algeria in 2010 to that in 2011?
Provide a succinct answer. 0.68. What is the ratio of the Expenses (in $) of Botswana in 2010 to that in 2011?
Provide a short and direct response. 0.93. What is the ratio of the Expenses (in $) in Grenada in 2010 to that in 2011?
Your answer should be compact. 0.97. What is the ratio of the Expenses (in $) of Slovak Republic in 2010 to that in 2011?
Provide a short and direct response. 0.99. What is the difference between the highest and the second highest Expenses (in $) in Algeria?
Make the answer very short. 1.37e+12. What is the difference between the highest and the second highest Expenses (in $) of Botswana?
Your answer should be very brief. 2.00e+09. What is the difference between the highest and the second highest Expenses (in $) of Grenada?
Offer a terse response. 4.20e+06. What is the difference between the highest and the second highest Expenses (in $) of Slovak Republic?
Your response must be concise. 3.62e+08. What is the difference between the highest and the lowest Expenses (in $) of Algeria?
Your response must be concise. 2.68e+12. What is the difference between the highest and the lowest Expenses (in $) of Botswana?
Make the answer very short. 1.38e+1. What is the difference between the highest and the lowest Expenses (in $) of Grenada?
Keep it short and to the point. 1.03e+08. What is the difference between the highest and the lowest Expenses (in $) of Slovak Republic?
Provide a short and direct response. 5.24e+09. 